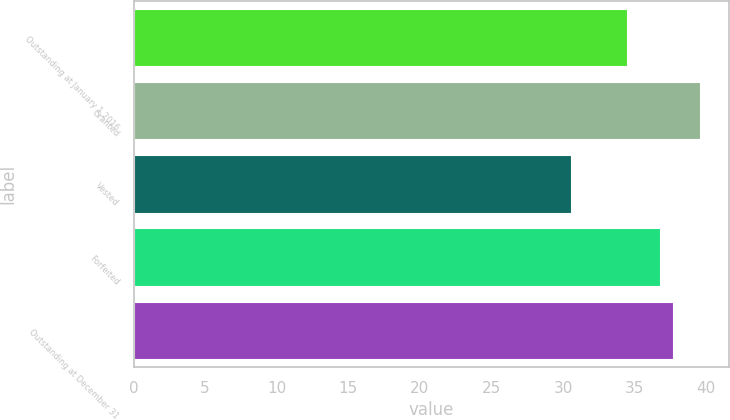Convert chart to OTSL. <chart><loc_0><loc_0><loc_500><loc_500><bar_chart><fcel>Outstanding at January 1 2016<fcel>Granted<fcel>Vested<fcel>Forfeited<fcel>Outstanding at December 31<nl><fcel>34.52<fcel>39.63<fcel>30.63<fcel>36.81<fcel>37.71<nl></chart> 